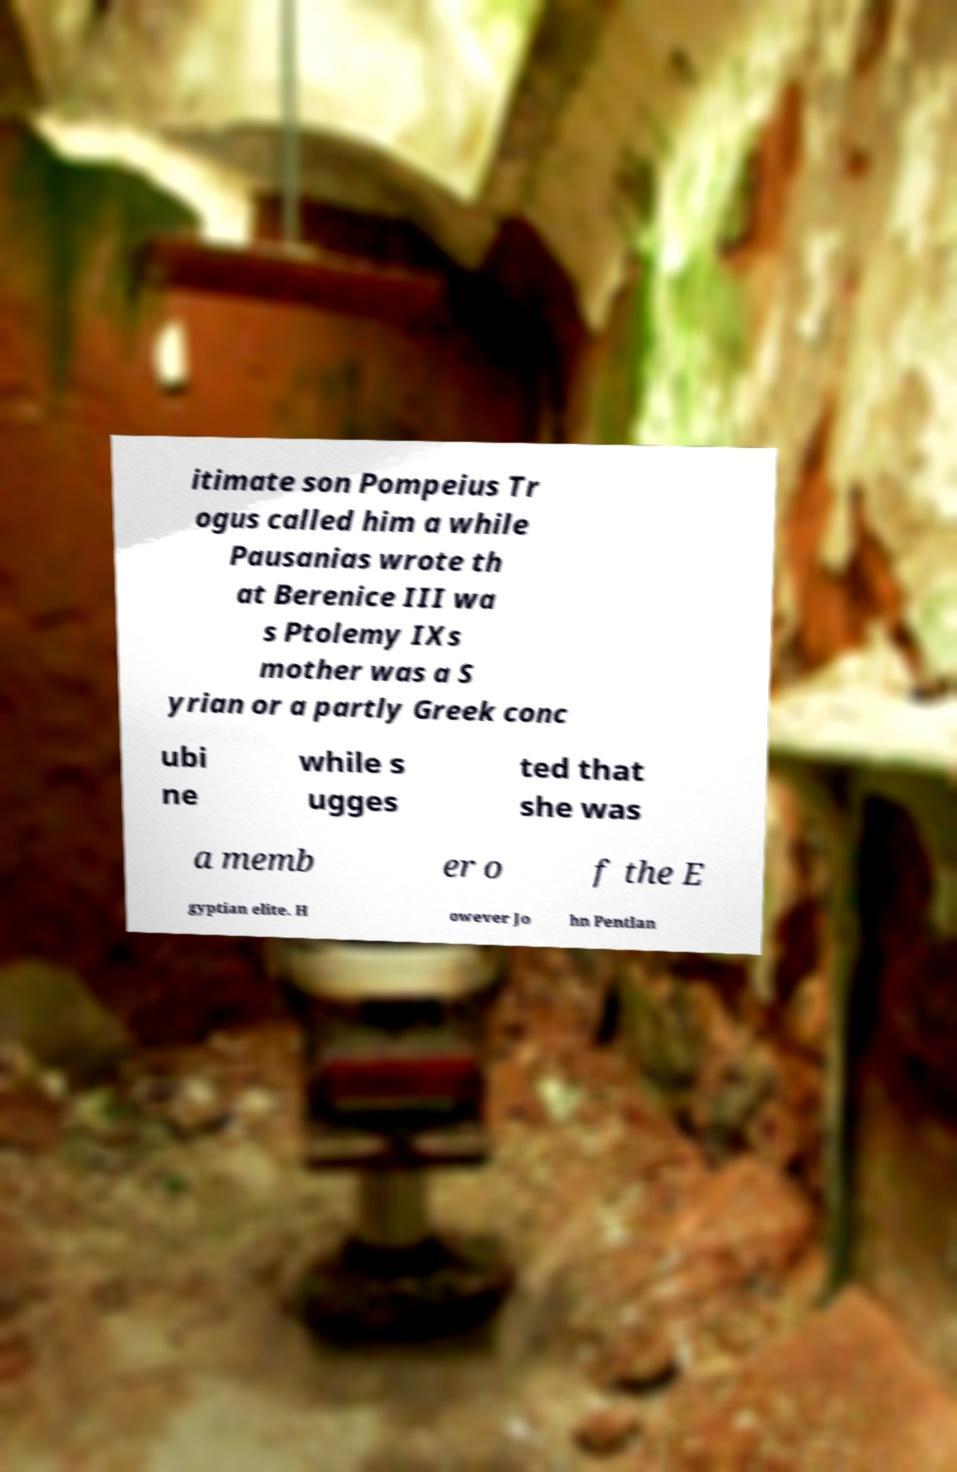I need the written content from this picture converted into text. Can you do that? itimate son Pompeius Tr ogus called him a while Pausanias wrote th at Berenice III wa s Ptolemy IXs mother was a S yrian or a partly Greek conc ubi ne while s ugges ted that she was a memb er o f the E gyptian elite. H owever Jo hn Pentlan 